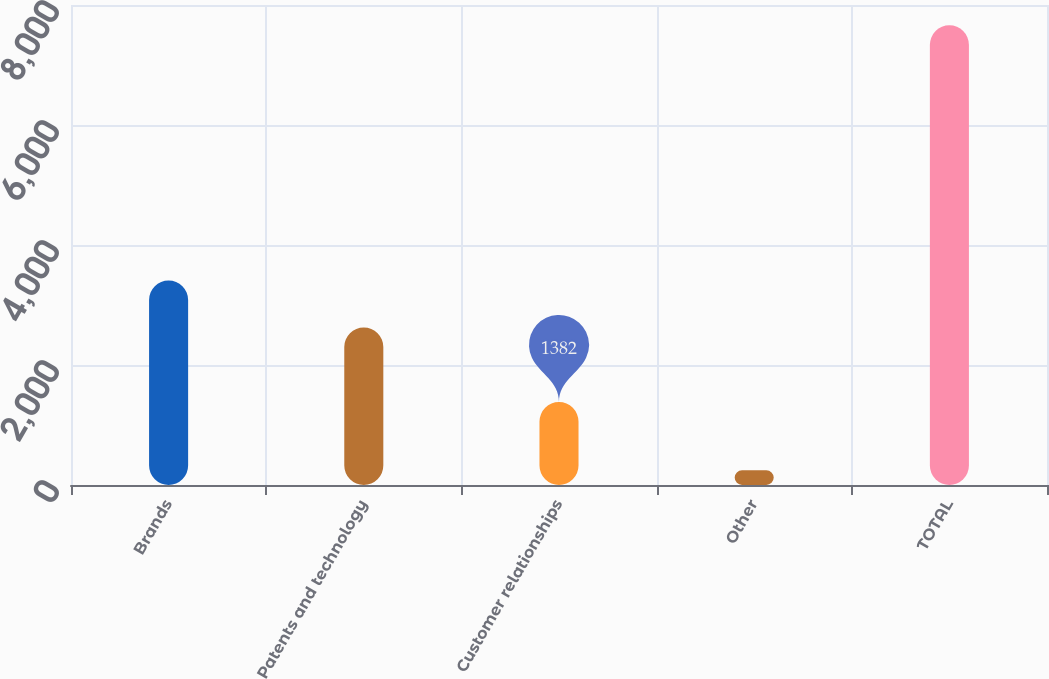Convert chart. <chart><loc_0><loc_0><loc_500><loc_500><bar_chart><fcel>Brands<fcel>Patents and technology<fcel>Customer relationships<fcel>Other<fcel>TOTAL<nl><fcel>3409<fcel>2624<fcel>1382<fcel>246<fcel>7661<nl></chart> 